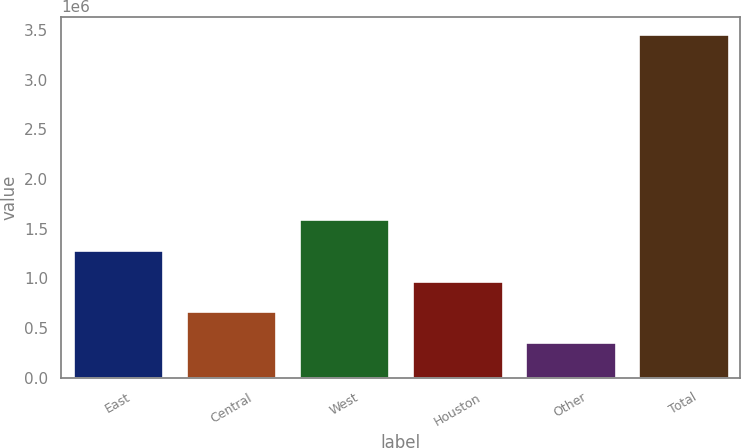Convert chart. <chart><loc_0><loc_0><loc_500><loc_500><bar_chart><fcel>East<fcel>Central<fcel>West<fcel>Houston<fcel>Other<fcel>Total<nl><fcel>1.2886e+06<fcel>668012<fcel>1.59889e+06<fcel>978305<fcel>357718<fcel>3.46065e+06<nl></chart> 